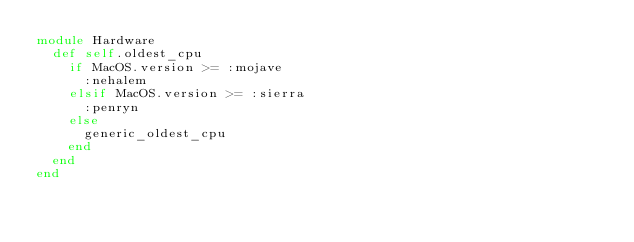<code> <loc_0><loc_0><loc_500><loc_500><_Ruby_>module Hardware
  def self.oldest_cpu
    if MacOS.version >= :mojave
      :nehalem
    elsif MacOS.version >= :sierra
      :penryn
    else
      generic_oldest_cpu
    end
  end
end
</code> 